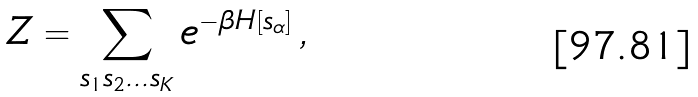<formula> <loc_0><loc_0><loc_500><loc_500>Z = \sum _ { s _ { 1 } s _ { 2 } \dots s _ { K } } e ^ { - \beta H [ s _ { \alpha } ] } \, ,</formula> 